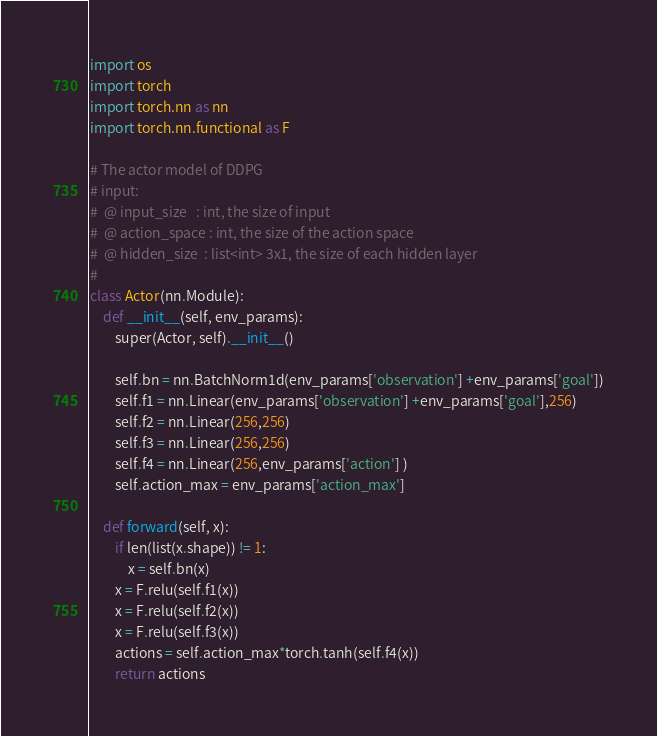<code> <loc_0><loc_0><loc_500><loc_500><_Python_>import os
import torch
import torch.nn as nn
import torch.nn.functional as F

# The actor model of DDPG
# input:
#  @ input_size   : int, the size of input
#  @ action_space : int, the size of the action space
#  @ hidden_size  : list<int> 3x1, the size of each hidden layer 
# 
class Actor(nn.Module):
    def __init__(self, env_params):
        super(Actor, self).__init__()

        self.bn = nn.BatchNorm1d(env_params['observation'] +env_params['goal'])
        self.f1 = nn.Linear(env_params['observation'] +env_params['goal'],256)
        self.f2 = nn.Linear(256,256)
        self.f3 = nn.Linear(256,256)
        self.f4 = nn.Linear(256,env_params['action'] )
        self.action_max = env_params['action_max']
        
    def forward(self, x):
        if len(list(x.shape)) != 1:
            x = self.bn(x)
        x = F.relu(self.f1(x))
        x = F.relu(self.f2(x))
        x = F.relu(self.f3(x))
        actions = self.action_max*torch.tanh(self.f4(x))
        return actions
</code> 